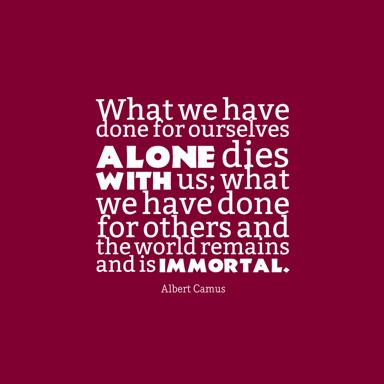What is the essence of the quote by Albert Camus? The quote by Albert Camus emphasizes the importance of helping others and leaving a positive impact on the world. It says, "What we have done for ourselves alone dies with us. What we have done for others and the world remains and is immortal." This means that our actions and contributions that benefit others and the world will have a lasting impact, even after we are gone, while our self-centered actions will perish with us. What does the color scheme represent in this image? The red background with a white square in the middle could represent a bold and vivid visual contrast, capturing attention and emphasizing the importance of Albert Camus' quote. The contrast may also symbolize the stark difference between focusing solely on oneself and making a lasting impact by contributing to the betterment of others and the world. 